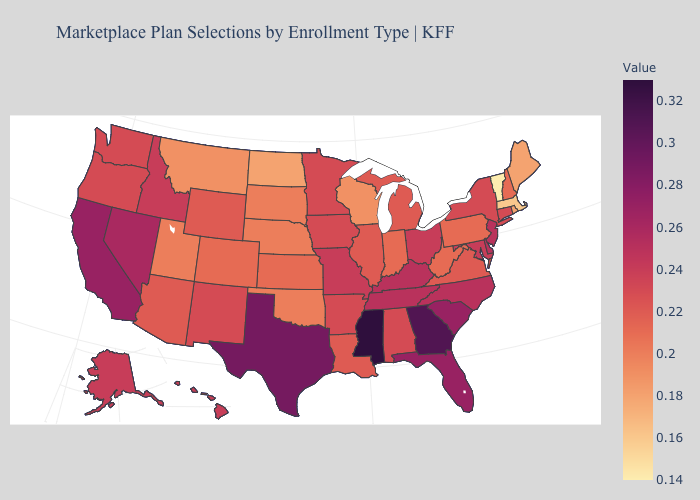Among the states that border New Hampshire , does Vermont have the lowest value?
Be succinct. Yes. Does Arizona have a higher value than Texas?
Concise answer only. No. Which states hav the highest value in the Northeast?
Write a very short answer. New Jersey. Does Alaska have the highest value in the West?
Be succinct. No. Which states have the lowest value in the USA?
Be succinct. Vermont. Which states have the highest value in the USA?
Short answer required. Mississippi. 